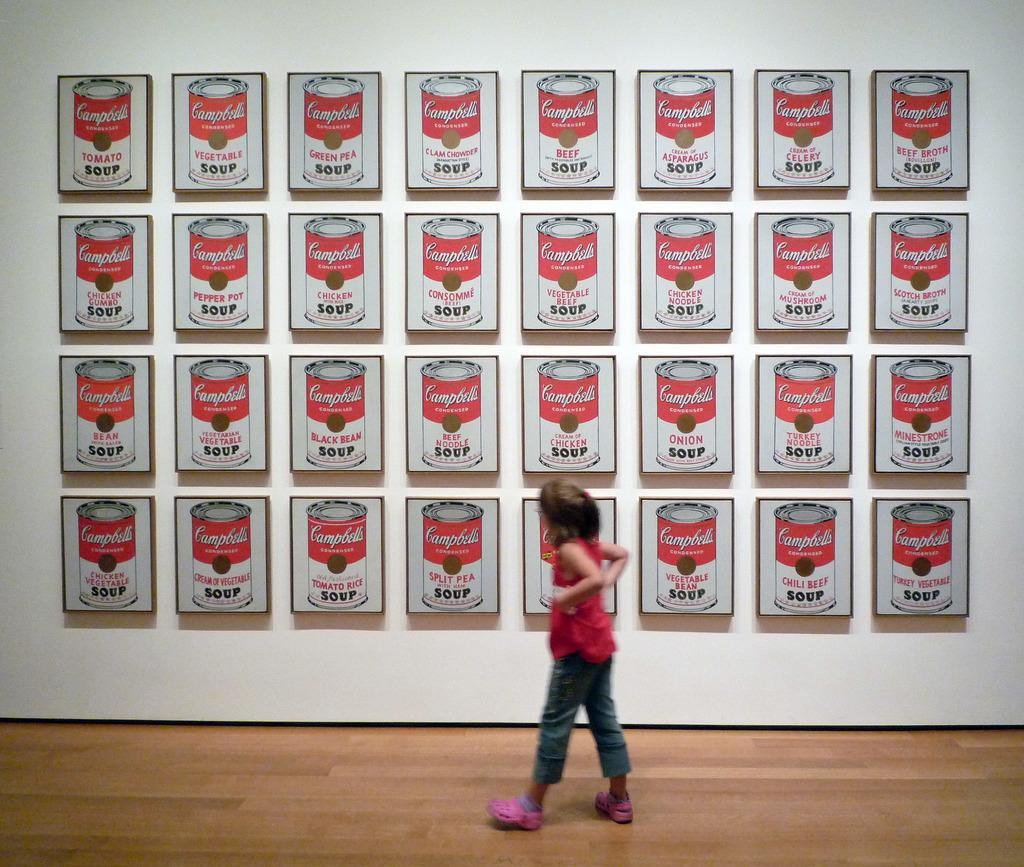In one or two sentences, can you explain what this image depicts? In this picture there is a girl on the floor. In the background of the image we can see boards on the wall. 